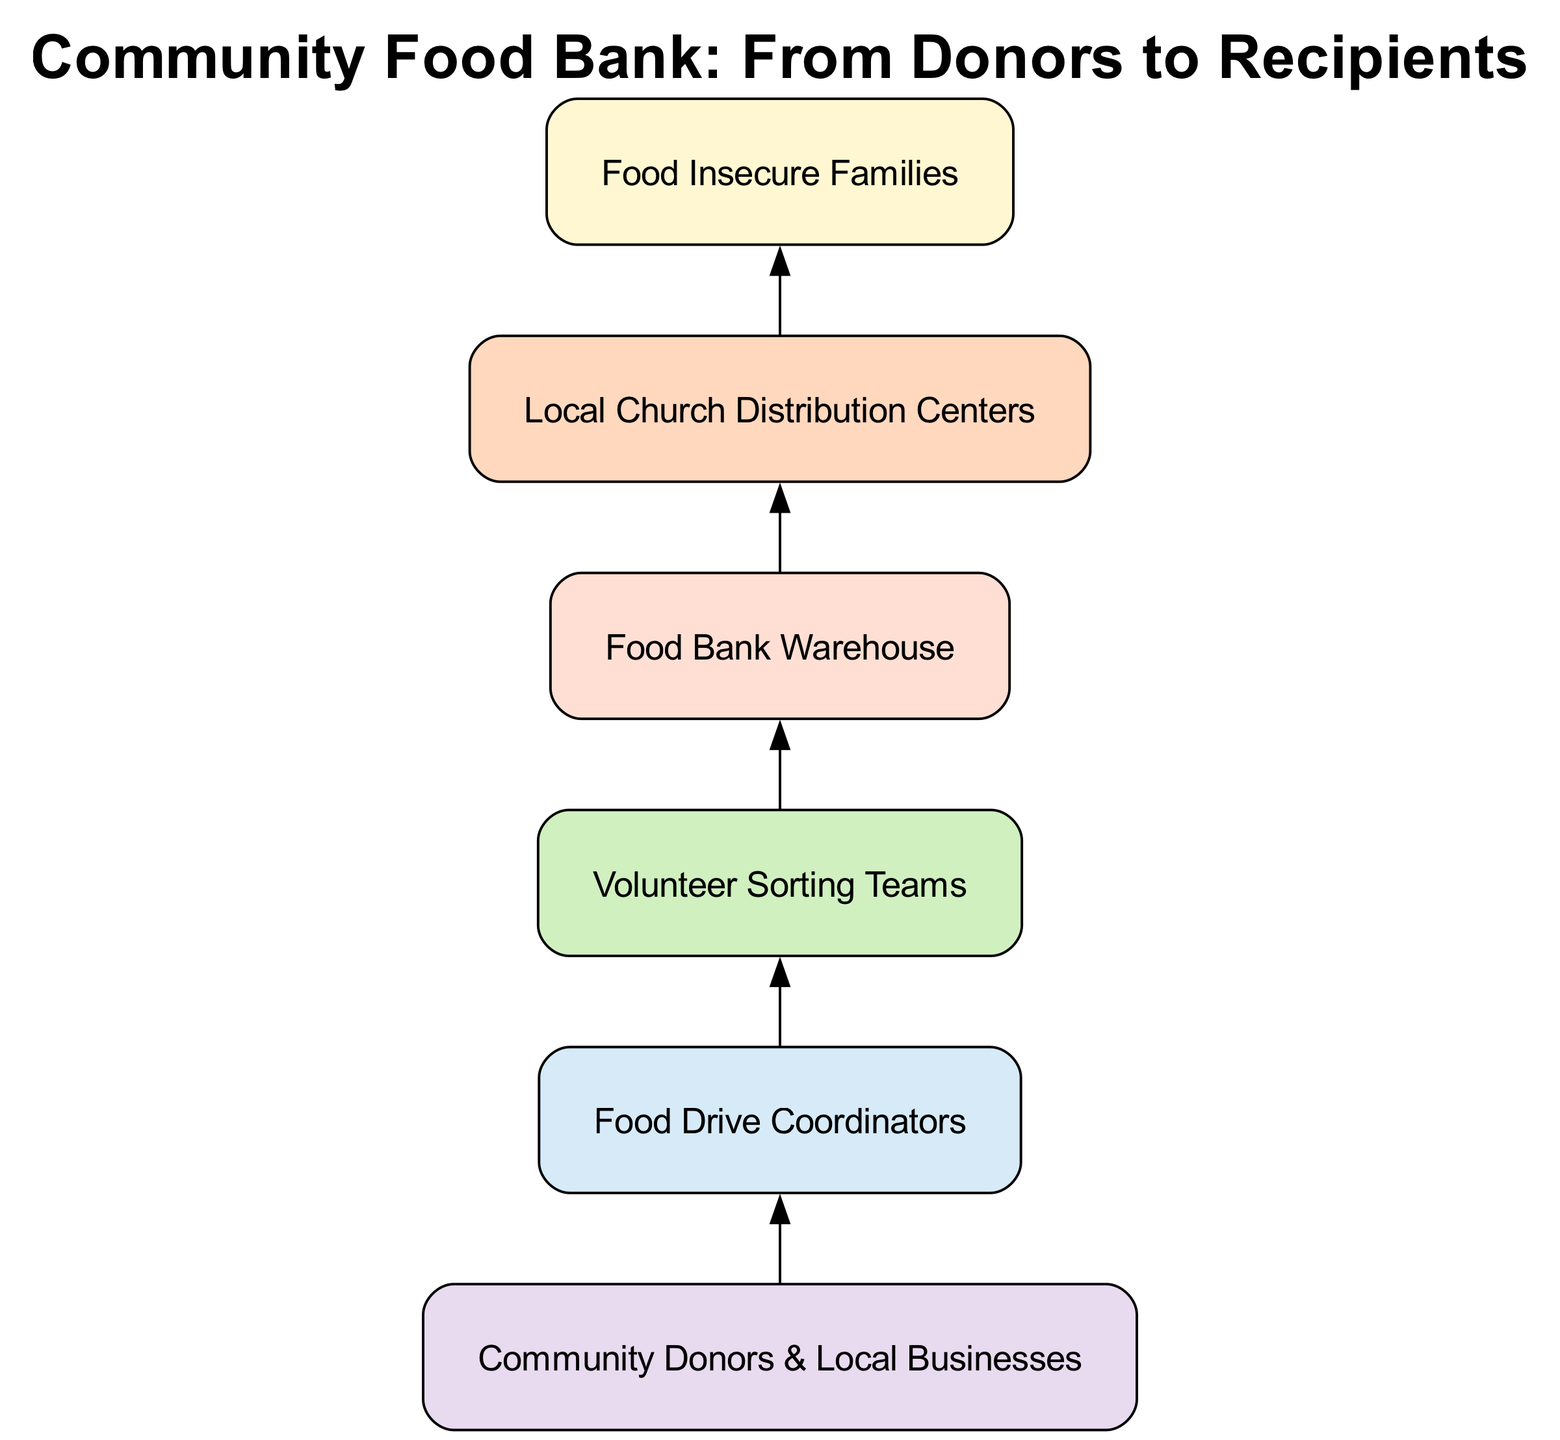What is the top node in the diagram? The top node is the last one in the flow from donors to recipients. By tracing the flow upward, you find that "Food Insecure Families" is the starting point that connects to all other nodes below.
Answer: Food Insecure Families How many nodes are in the diagram? Count all the distinct elements represented within the flow chart starting from "Food Insecure Families" to "Community Donors & Local Businesses". There are a total of six nodes listed in the structure.
Answer: 6 What connects "Volunteer Sorting Teams" to "Food Bank Warehouse"? Observe the direct connection labeled as an edge. The edge points from "Volunteer Sorting Teams" down to "Food Bank Warehouse," illustrating the flow of responsibility or material.
Answer: sorting Who are the primary donors depicted in the diagram? The diagram specifically identifies "Community Donors & Local Businesses" as the main contributing entities, indicating where the resources originate before reaching the recipients.
Answer: Community Donors & Local Businesses Which node has the most connections? By analyzing the structure, you compare the child nodes of each element. "Food Drive Coordinators" connects directly to the "Volunteer Sorting Teams," which in turn connect to "Food Bank Warehouse," indicating a higher level of interaction.
Answer: collection How many levels are in the hierarchy? The flow can be visually traced from the recipients at the top down through different levels of processing, including donors, collection, sorting, inventory, and distribution. This results in one starting level and five additional, making a total of six.
Answer: 6 What is the last process before distribution? Following the flow upwards from recipients, the last process labeled before reaching the "Local Church Distribution Centers" is "Food Bank Warehouse," indicating that this step is necessary before food distribution occurs.
Answer: inventory What relationship exists between "Food Drive Coordinators" and "Local Church Distribution Centers"? "Food Drive Coordinators" connects to "Volunteer Sorting Teams," which link down to "Local Church Distribution Centers," creating a two-level relationship indicating a direct set of responsibilities in food distribution.
Answer: collection to distribution What is the final outcome of this food bank structure? The final outcome is when the structure reaches its top node once all previous processing has occurred. Ultimately, these processes transition resources to "Food Insecure Families" at the end of the line flow.
Answer: Food Insecure Families 